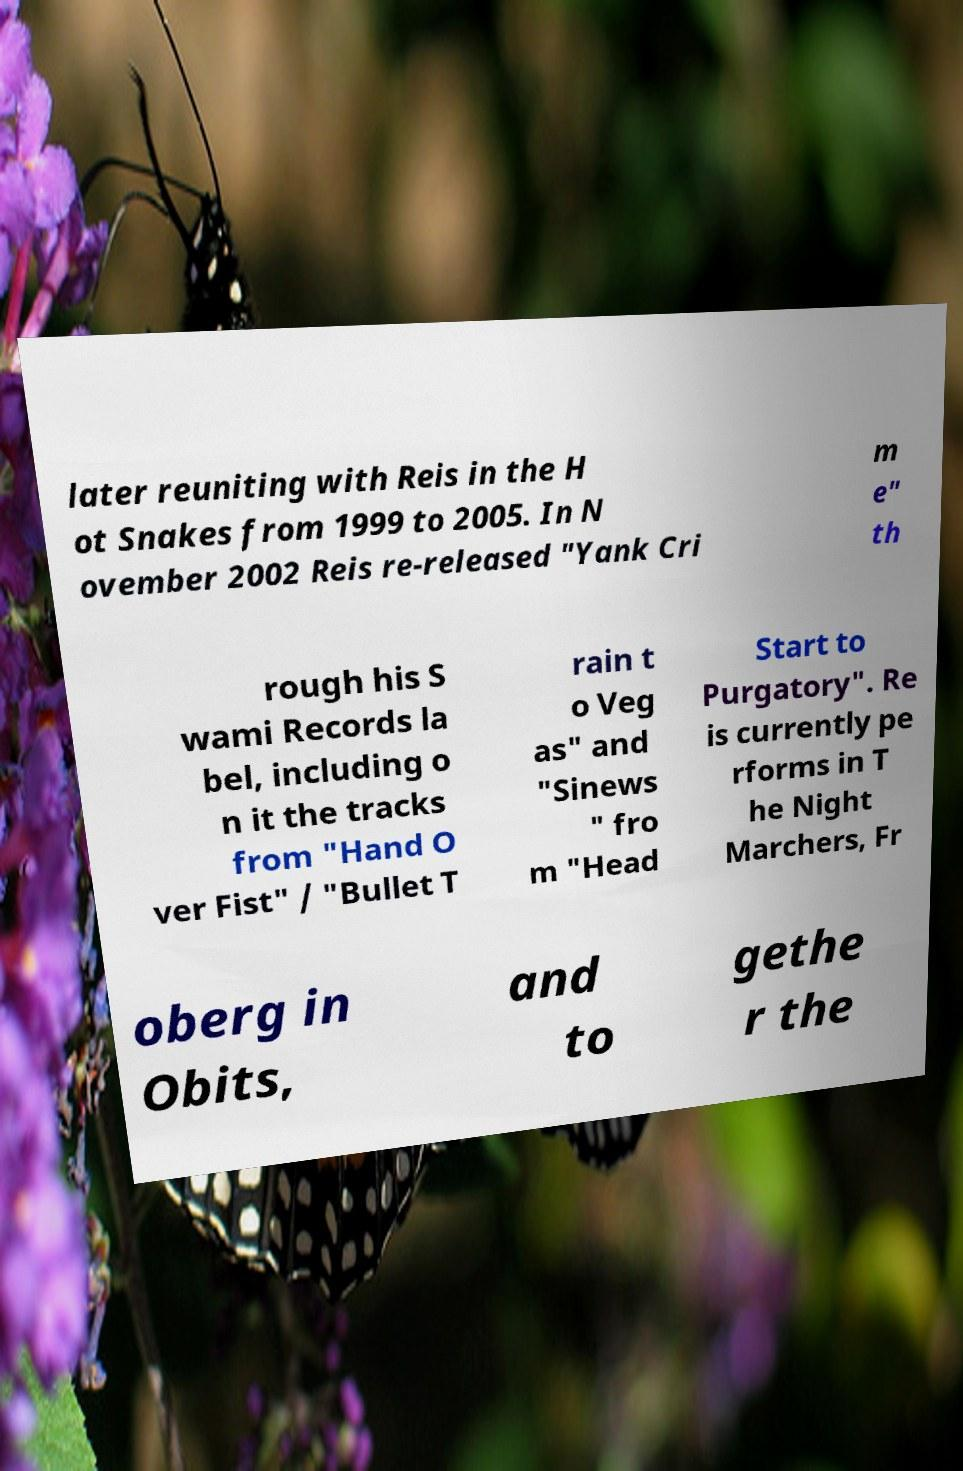Please read and relay the text visible in this image. What does it say? later reuniting with Reis in the H ot Snakes from 1999 to 2005. In N ovember 2002 Reis re-released "Yank Cri m e" th rough his S wami Records la bel, including o n it the tracks from "Hand O ver Fist" / "Bullet T rain t o Veg as" and "Sinews " fro m "Head Start to Purgatory". Re is currently pe rforms in T he Night Marchers, Fr oberg in Obits, and to gethe r the 